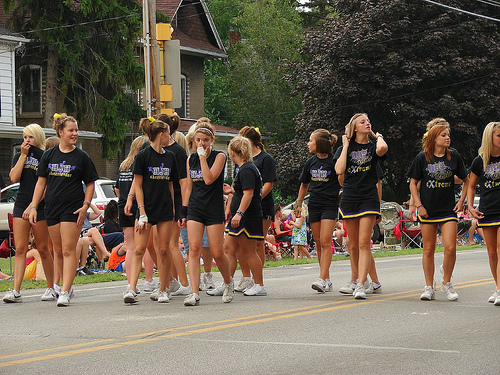<image>
Is the girl behind the girl? No. The girl is not behind the girl. From this viewpoint, the girl appears to be positioned elsewhere in the scene. 